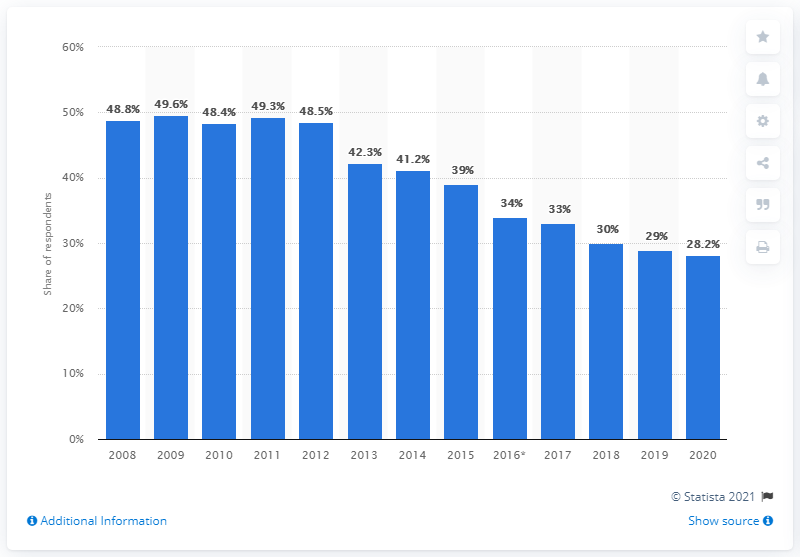Identify some key points in this picture. The survey examined the perception of fairness of gambling in the UK in the year 2009. 